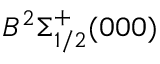Convert formula to latex. <formula><loc_0><loc_0><loc_500><loc_500>B ^ { 2 } \Sigma _ { 1 / 2 } ^ { + } ( 0 0 0 )</formula> 